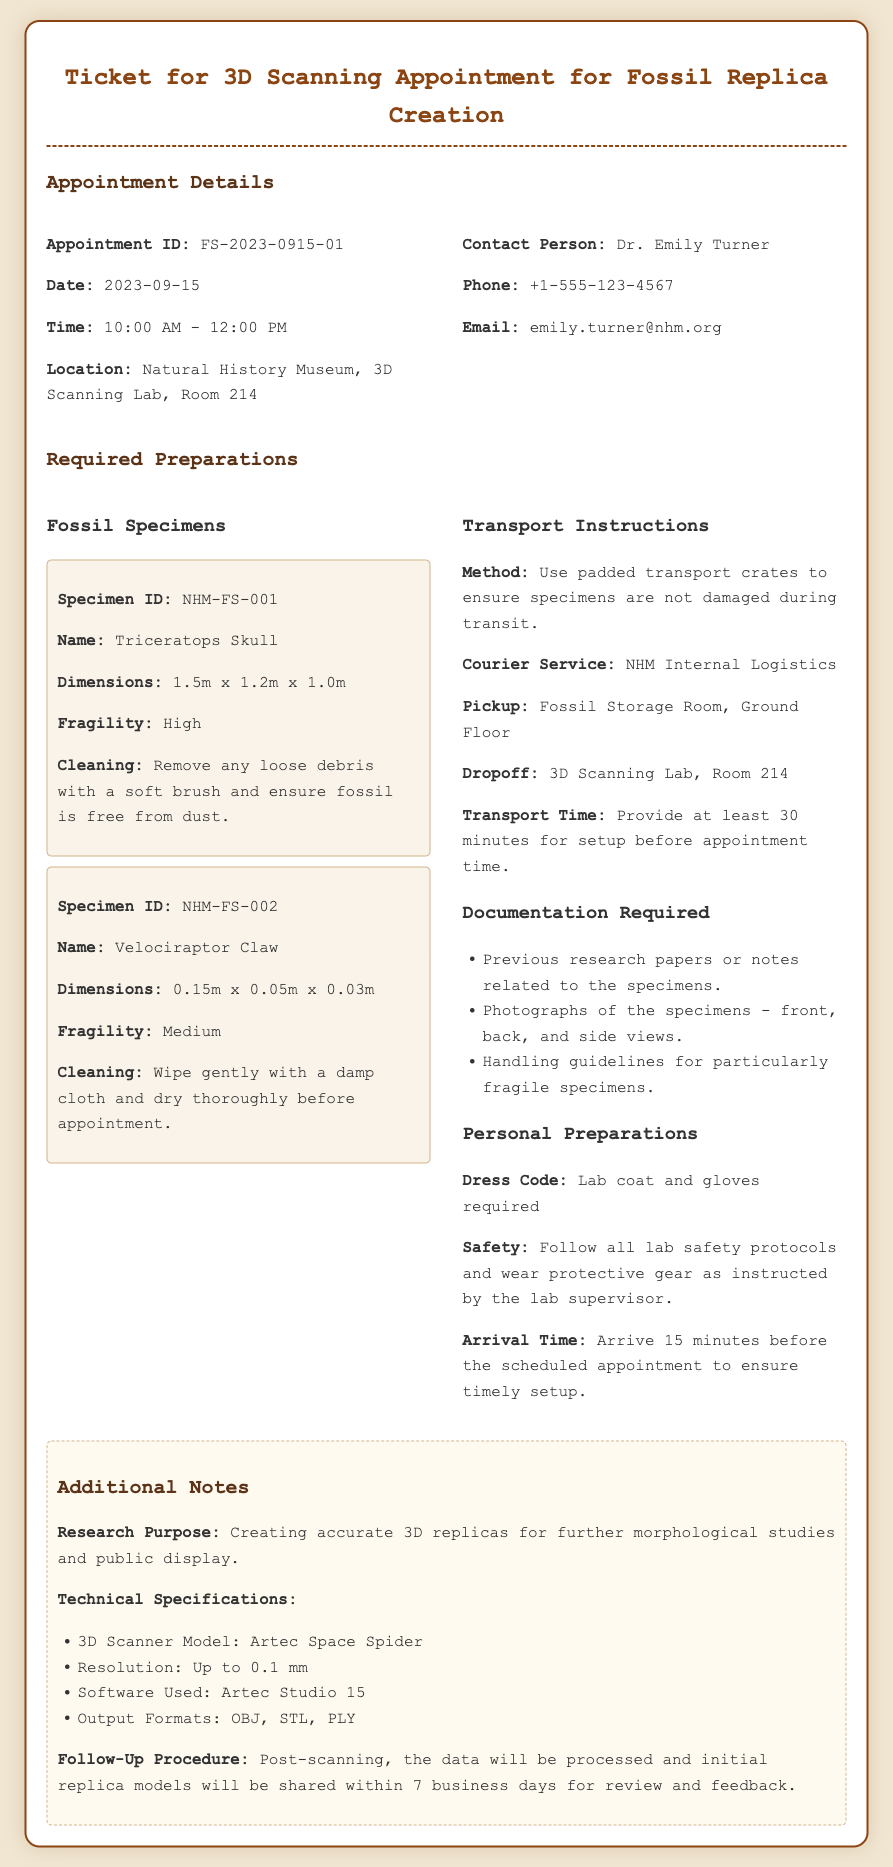What is the Appointment ID? The Appointment ID is a unique identifier for the appointment listed in the document.
Answer: FS-2023-0915-01 What is the Date of the appointment? The date of the appointment is specified in the document.
Answer: 2023-09-15 Who is the Contact Person? The contact person for the appointment is mentioned in the document.
Answer: Dr. Emily Turner What are the dimensions of the Triceratops Skull? The dimensions of the Triceratops Skull specimen are detailed in the document.
Answer: 1.5m x 1.2m x 1.0m What is the required dress code? The document states specific clothing requirements for attending the appointment.
Answer: Lab coat and gloves required What is the transport method for the specimens? The document specifies how the specimens should be transported to avoid damage.
Answer: Use padded transport crates What is the resolution of the 3D Scanner Model? The resolution is a technical specification provided in the document.
Answer: Up to 0.1 mm How long should one arrive before the scheduled appointment? The recommended arrival time is mentioned in the preparations section.
Answer: 15 minutes before What is the purpose of the research? The document notes the purpose of the 3D scanning work.
Answer: Creating accurate 3D replicas for further morphological studies and public display 